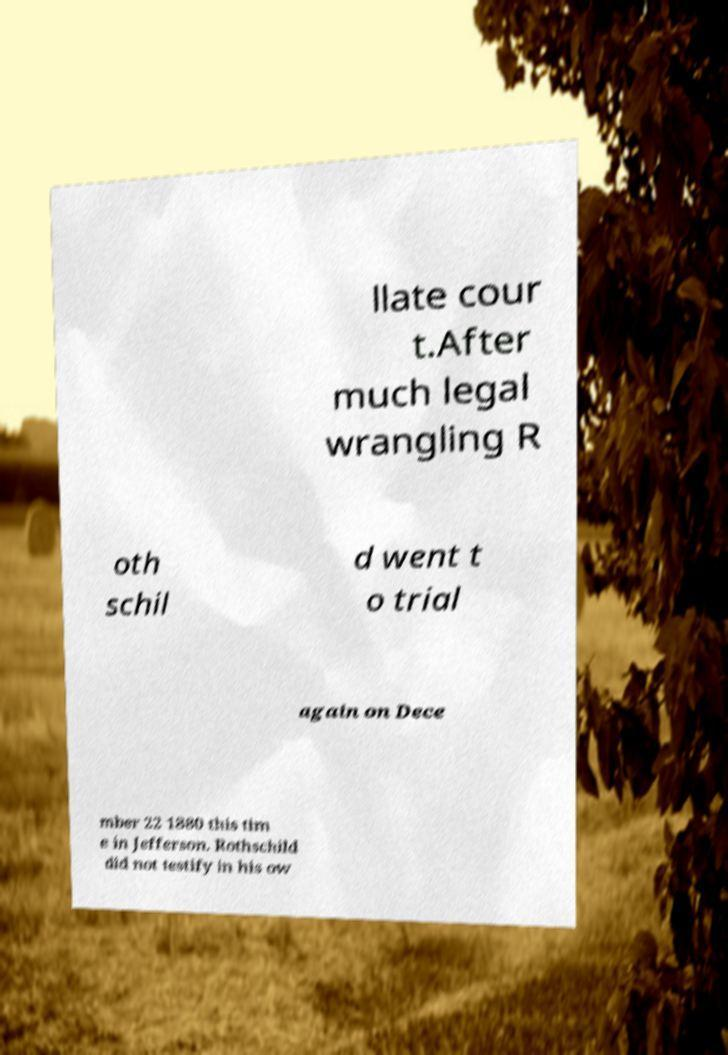I need the written content from this picture converted into text. Can you do that? llate cour t.After much legal wrangling R oth schil d went t o trial again on Dece mber 22 1880 this tim e in Jefferson. Rothschild did not testify in his ow 